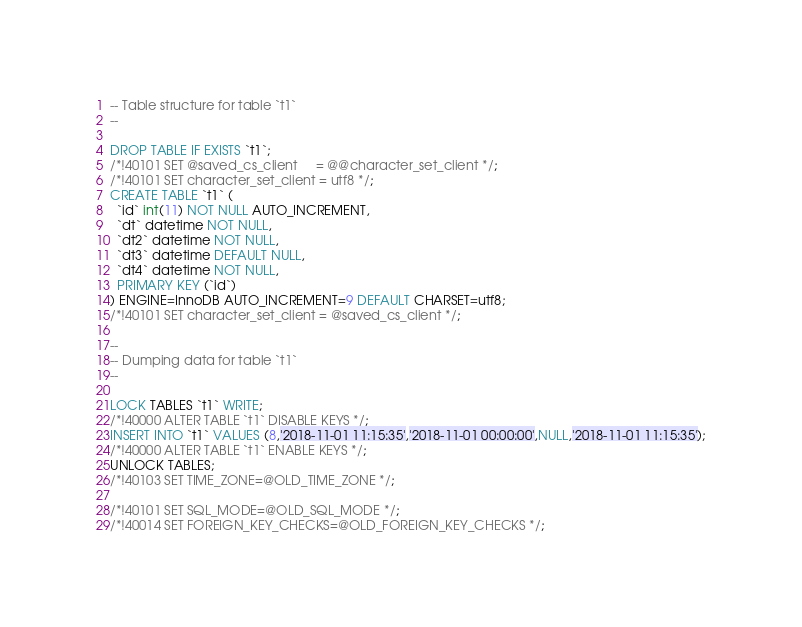<code> <loc_0><loc_0><loc_500><loc_500><_SQL_>-- Table structure for table `t1`
--

DROP TABLE IF EXISTS `t1`;
/*!40101 SET @saved_cs_client     = @@character_set_client */;
/*!40101 SET character_set_client = utf8 */;
CREATE TABLE `t1` (
  `id` int(11) NOT NULL AUTO_INCREMENT,
  `dt` datetime NOT NULL,
  `dt2` datetime NOT NULL,
  `dt3` datetime DEFAULT NULL,
  `dt4` datetime NOT NULL,
  PRIMARY KEY (`id`)
) ENGINE=InnoDB AUTO_INCREMENT=9 DEFAULT CHARSET=utf8;
/*!40101 SET character_set_client = @saved_cs_client */;

--
-- Dumping data for table `t1`
--

LOCK TABLES `t1` WRITE;
/*!40000 ALTER TABLE `t1` DISABLE KEYS */;
INSERT INTO `t1` VALUES (8,'2018-11-01 11:15:35','2018-11-01 00:00:00',NULL,'2018-11-01 11:15:35');
/*!40000 ALTER TABLE `t1` ENABLE KEYS */;
UNLOCK TABLES;
/*!40103 SET TIME_ZONE=@OLD_TIME_ZONE */;

/*!40101 SET SQL_MODE=@OLD_SQL_MODE */;
/*!40014 SET FOREIGN_KEY_CHECKS=@OLD_FOREIGN_KEY_CHECKS */;</code> 